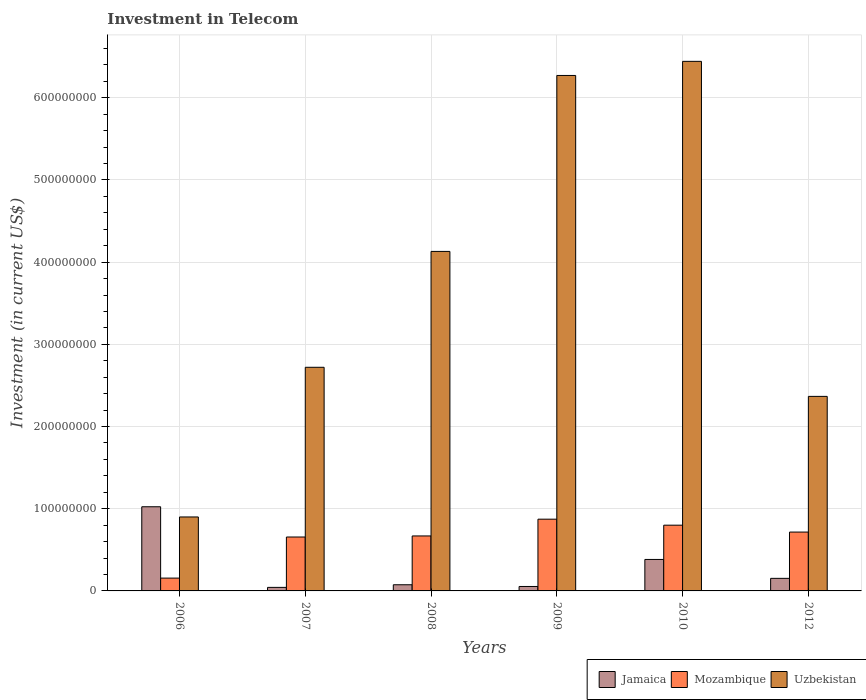How many groups of bars are there?
Your response must be concise. 6. Are the number of bars per tick equal to the number of legend labels?
Provide a short and direct response. Yes. Are the number of bars on each tick of the X-axis equal?
Make the answer very short. Yes. What is the label of the 1st group of bars from the left?
Offer a very short reply. 2006. What is the amount invested in telecom in Jamaica in 2006?
Your answer should be very brief. 1.02e+08. Across all years, what is the maximum amount invested in telecom in Uzbekistan?
Your answer should be compact. 6.44e+08. Across all years, what is the minimum amount invested in telecom in Uzbekistan?
Make the answer very short. 9.00e+07. What is the total amount invested in telecom in Uzbekistan in the graph?
Your answer should be compact. 2.28e+09. What is the difference between the amount invested in telecom in Mozambique in 2007 and that in 2008?
Provide a succinct answer. -1.30e+06. What is the difference between the amount invested in telecom in Jamaica in 2010 and the amount invested in telecom in Mozambique in 2006?
Offer a very short reply. 2.27e+07. What is the average amount invested in telecom in Mozambique per year?
Your answer should be compact. 6.45e+07. In the year 2009, what is the difference between the amount invested in telecom in Mozambique and amount invested in telecom in Jamaica?
Make the answer very short. 8.19e+07. What is the ratio of the amount invested in telecom in Mozambique in 2010 to that in 2012?
Your answer should be very brief. 1.12. Is the amount invested in telecom in Mozambique in 2008 less than that in 2012?
Keep it short and to the point. Yes. Is the difference between the amount invested in telecom in Mozambique in 2007 and 2012 greater than the difference between the amount invested in telecom in Jamaica in 2007 and 2012?
Your response must be concise. Yes. What is the difference between the highest and the second highest amount invested in telecom in Mozambique?
Give a very brief answer. 7.30e+06. What is the difference between the highest and the lowest amount invested in telecom in Uzbekistan?
Offer a terse response. 5.54e+08. Is the sum of the amount invested in telecom in Mozambique in 2008 and 2012 greater than the maximum amount invested in telecom in Jamaica across all years?
Provide a succinct answer. Yes. What does the 1st bar from the left in 2009 represents?
Your answer should be compact. Jamaica. What does the 3rd bar from the right in 2012 represents?
Your response must be concise. Jamaica. How many years are there in the graph?
Make the answer very short. 6. Are the values on the major ticks of Y-axis written in scientific E-notation?
Keep it short and to the point. No. How many legend labels are there?
Give a very brief answer. 3. What is the title of the graph?
Make the answer very short. Investment in Telecom. Does "Afghanistan" appear as one of the legend labels in the graph?
Ensure brevity in your answer.  No. What is the label or title of the X-axis?
Make the answer very short. Years. What is the label or title of the Y-axis?
Your answer should be very brief. Investment (in current US$). What is the Investment (in current US$) of Jamaica in 2006?
Offer a terse response. 1.02e+08. What is the Investment (in current US$) in Mozambique in 2006?
Provide a succinct answer. 1.56e+07. What is the Investment (in current US$) of Uzbekistan in 2006?
Your response must be concise. 9.00e+07. What is the Investment (in current US$) of Jamaica in 2007?
Keep it short and to the point. 4.30e+06. What is the Investment (in current US$) of Mozambique in 2007?
Your answer should be compact. 6.56e+07. What is the Investment (in current US$) of Uzbekistan in 2007?
Ensure brevity in your answer.  2.72e+08. What is the Investment (in current US$) of Jamaica in 2008?
Provide a short and direct response. 7.50e+06. What is the Investment (in current US$) of Mozambique in 2008?
Your answer should be compact. 6.69e+07. What is the Investment (in current US$) in Uzbekistan in 2008?
Offer a terse response. 4.13e+08. What is the Investment (in current US$) in Jamaica in 2009?
Your answer should be very brief. 5.40e+06. What is the Investment (in current US$) in Mozambique in 2009?
Your answer should be compact. 8.73e+07. What is the Investment (in current US$) in Uzbekistan in 2009?
Provide a succinct answer. 6.27e+08. What is the Investment (in current US$) in Jamaica in 2010?
Keep it short and to the point. 3.83e+07. What is the Investment (in current US$) of Mozambique in 2010?
Offer a very short reply. 8.00e+07. What is the Investment (in current US$) of Uzbekistan in 2010?
Keep it short and to the point. 6.44e+08. What is the Investment (in current US$) of Jamaica in 2012?
Offer a terse response. 1.53e+07. What is the Investment (in current US$) of Mozambique in 2012?
Keep it short and to the point. 7.16e+07. What is the Investment (in current US$) in Uzbekistan in 2012?
Provide a short and direct response. 2.37e+08. Across all years, what is the maximum Investment (in current US$) of Jamaica?
Provide a short and direct response. 1.02e+08. Across all years, what is the maximum Investment (in current US$) in Mozambique?
Give a very brief answer. 8.73e+07. Across all years, what is the maximum Investment (in current US$) of Uzbekistan?
Offer a very short reply. 6.44e+08. Across all years, what is the minimum Investment (in current US$) of Jamaica?
Make the answer very short. 4.30e+06. Across all years, what is the minimum Investment (in current US$) of Mozambique?
Make the answer very short. 1.56e+07. Across all years, what is the minimum Investment (in current US$) in Uzbekistan?
Make the answer very short. 9.00e+07. What is the total Investment (in current US$) in Jamaica in the graph?
Make the answer very short. 1.73e+08. What is the total Investment (in current US$) in Mozambique in the graph?
Make the answer very short. 3.87e+08. What is the total Investment (in current US$) of Uzbekistan in the graph?
Offer a terse response. 2.28e+09. What is the difference between the Investment (in current US$) in Jamaica in 2006 and that in 2007?
Provide a succinct answer. 9.81e+07. What is the difference between the Investment (in current US$) in Mozambique in 2006 and that in 2007?
Your response must be concise. -5.00e+07. What is the difference between the Investment (in current US$) of Uzbekistan in 2006 and that in 2007?
Your answer should be very brief. -1.82e+08. What is the difference between the Investment (in current US$) in Jamaica in 2006 and that in 2008?
Your answer should be compact. 9.49e+07. What is the difference between the Investment (in current US$) in Mozambique in 2006 and that in 2008?
Your response must be concise. -5.13e+07. What is the difference between the Investment (in current US$) in Uzbekistan in 2006 and that in 2008?
Your answer should be very brief. -3.23e+08. What is the difference between the Investment (in current US$) of Jamaica in 2006 and that in 2009?
Give a very brief answer. 9.70e+07. What is the difference between the Investment (in current US$) of Mozambique in 2006 and that in 2009?
Give a very brief answer. -7.17e+07. What is the difference between the Investment (in current US$) in Uzbekistan in 2006 and that in 2009?
Keep it short and to the point. -5.37e+08. What is the difference between the Investment (in current US$) of Jamaica in 2006 and that in 2010?
Offer a very short reply. 6.41e+07. What is the difference between the Investment (in current US$) of Mozambique in 2006 and that in 2010?
Offer a terse response. -6.44e+07. What is the difference between the Investment (in current US$) of Uzbekistan in 2006 and that in 2010?
Provide a short and direct response. -5.54e+08. What is the difference between the Investment (in current US$) in Jamaica in 2006 and that in 2012?
Your answer should be very brief. 8.71e+07. What is the difference between the Investment (in current US$) in Mozambique in 2006 and that in 2012?
Provide a short and direct response. -5.60e+07. What is the difference between the Investment (in current US$) of Uzbekistan in 2006 and that in 2012?
Offer a very short reply. -1.47e+08. What is the difference between the Investment (in current US$) of Jamaica in 2007 and that in 2008?
Ensure brevity in your answer.  -3.20e+06. What is the difference between the Investment (in current US$) in Mozambique in 2007 and that in 2008?
Provide a short and direct response. -1.30e+06. What is the difference between the Investment (in current US$) of Uzbekistan in 2007 and that in 2008?
Provide a succinct answer. -1.41e+08. What is the difference between the Investment (in current US$) of Jamaica in 2007 and that in 2009?
Ensure brevity in your answer.  -1.10e+06. What is the difference between the Investment (in current US$) in Mozambique in 2007 and that in 2009?
Ensure brevity in your answer.  -2.17e+07. What is the difference between the Investment (in current US$) of Uzbekistan in 2007 and that in 2009?
Provide a succinct answer. -3.55e+08. What is the difference between the Investment (in current US$) in Jamaica in 2007 and that in 2010?
Your answer should be compact. -3.40e+07. What is the difference between the Investment (in current US$) of Mozambique in 2007 and that in 2010?
Make the answer very short. -1.44e+07. What is the difference between the Investment (in current US$) of Uzbekistan in 2007 and that in 2010?
Your response must be concise. -3.72e+08. What is the difference between the Investment (in current US$) of Jamaica in 2007 and that in 2012?
Give a very brief answer. -1.10e+07. What is the difference between the Investment (in current US$) in Mozambique in 2007 and that in 2012?
Keep it short and to the point. -6.00e+06. What is the difference between the Investment (in current US$) of Uzbekistan in 2007 and that in 2012?
Provide a succinct answer. 3.54e+07. What is the difference between the Investment (in current US$) in Jamaica in 2008 and that in 2009?
Your answer should be very brief. 2.10e+06. What is the difference between the Investment (in current US$) of Mozambique in 2008 and that in 2009?
Provide a succinct answer. -2.04e+07. What is the difference between the Investment (in current US$) of Uzbekistan in 2008 and that in 2009?
Provide a short and direct response. -2.14e+08. What is the difference between the Investment (in current US$) in Jamaica in 2008 and that in 2010?
Your answer should be very brief. -3.08e+07. What is the difference between the Investment (in current US$) in Mozambique in 2008 and that in 2010?
Your answer should be compact. -1.31e+07. What is the difference between the Investment (in current US$) in Uzbekistan in 2008 and that in 2010?
Your response must be concise. -2.31e+08. What is the difference between the Investment (in current US$) in Jamaica in 2008 and that in 2012?
Offer a very short reply. -7.80e+06. What is the difference between the Investment (in current US$) of Mozambique in 2008 and that in 2012?
Offer a very short reply. -4.70e+06. What is the difference between the Investment (in current US$) in Uzbekistan in 2008 and that in 2012?
Offer a very short reply. 1.76e+08. What is the difference between the Investment (in current US$) in Jamaica in 2009 and that in 2010?
Offer a terse response. -3.29e+07. What is the difference between the Investment (in current US$) in Mozambique in 2009 and that in 2010?
Your answer should be compact. 7.30e+06. What is the difference between the Investment (in current US$) of Uzbekistan in 2009 and that in 2010?
Offer a very short reply. -1.72e+07. What is the difference between the Investment (in current US$) of Jamaica in 2009 and that in 2012?
Offer a terse response. -9.90e+06. What is the difference between the Investment (in current US$) of Mozambique in 2009 and that in 2012?
Provide a short and direct response. 1.57e+07. What is the difference between the Investment (in current US$) of Uzbekistan in 2009 and that in 2012?
Ensure brevity in your answer.  3.90e+08. What is the difference between the Investment (in current US$) of Jamaica in 2010 and that in 2012?
Offer a terse response. 2.30e+07. What is the difference between the Investment (in current US$) of Mozambique in 2010 and that in 2012?
Your response must be concise. 8.40e+06. What is the difference between the Investment (in current US$) in Uzbekistan in 2010 and that in 2012?
Give a very brief answer. 4.08e+08. What is the difference between the Investment (in current US$) of Jamaica in 2006 and the Investment (in current US$) of Mozambique in 2007?
Offer a terse response. 3.68e+07. What is the difference between the Investment (in current US$) of Jamaica in 2006 and the Investment (in current US$) of Uzbekistan in 2007?
Your answer should be very brief. -1.70e+08. What is the difference between the Investment (in current US$) of Mozambique in 2006 and the Investment (in current US$) of Uzbekistan in 2007?
Give a very brief answer. -2.56e+08. What is the difference between the Investment (in current US$) of Jamaica in 2006 and the Investment (in current US$) of Mozambique in 2008?
Keep it short and to the point. 3.55e+07. What is the difference between the Investment (in current US$) in Jamaica in 2006 and the Investment (in current US$) in Uzbekistan in 2008?
Offer a terse response. -3.11e+08. What is the difference between the Investment (in current US$) of Mozambique in 2006 and the Investment (in current US$) of Uzbekistan in 2008?
Your response must be concise. -3.98e+08. What is the difference between the Investment (in current US$) of Jamaica in 2006 and the Investment (in current US$) of Mozambique in 2009?
Your response must be concise. 1.51e+07. What is the difference between the Investment (in current US$) in Jamaica in 2006 and the Investment (in current US$) in Uzbekistan in 2009?
Offer a terse response. -5.25e+08. What is the difference between the Investment (in current US$) in Mozambique in 2006 and the Investment (in current US$) in Uzbekistan in 2009?
Your answer should be very brief. -6.12e+08. What is the difference between the Investment (in current US$) in Jamaica in 2006 and the Investment (in current US$) in Mozambique in 2010?
Make the answer very short. 2.24e+07. What is the difference between the Investment (in current US$) in Jamaica in 2006 and the Investment (in current US$) in Uzbekistan in 2010?
Keep it short and to the point. -5.42e+08. What is the difference between the Investment (in current US$) in Mozambique in 2006 and the Investment (in current US$) in Uzbekistan in 2010?
Your answer should be compact. -6.29e+08. What is the difference between the Investment (in current US$) of Jamaica in 2006 and the Investment (in current US$) of Mozambique in 2012?
Your response must be concise. 3.08e+07. What is the difference between the Investment (in current US$) in Jamaica in 2006 and the Investment (in current US$) in Uzbekistan in 2012?
Make the answer very short. -1.34e+08. What is the difference between the Investment (in current US$) of Mozambique in 2006 and the Investment (in current US$) of Uzbekistan in 2012?
Your response must be concise. -2.21e+08. What is the difference between the Investment (in current US$) of Jamaica in 2007 and the Investment (in current US$) of Mozambique in 2008?
Offer a very short reply. -6.26e+07. What is the difference between the Investment (in current US$) in Jamaica in 2007 and the Investment (in current US$) in Uzbekistan in 2008?
Ensure brevity in your answer.  -4.09e+08. What is the difference between the Investment (in current US$) of Mozambique in 2007 and the Investment (in current US$) of Uzbekistan in 2008?
Your response must be concise. -3.48e+08. What is the difference between the Investment (in current US$) of Jamaica in 2007 and the Investment (in current US$) of Mozambique in 2009?
Offer a terse response. -8.30e+07. What is the difference between the Investment (in current US$) in Jamaica in 2007 and the Investment (in current US$) in Uzbekistan in 2009?
Give a very brief answer. -6.23e+08. What is the difference between the Investment (in current US$) of Mozambique in 2007 and the Investment (in current US$) of Uzbekistan in 2009?
Offer a terse response. -5.62e+08. What is the difference between the Investment (in current US$) of Jamaica in 2007 and the Investment (in current US$) of Mozambique in 2010?
Keep it short and to the point. -7.57e+07. What is the difference between the Investment (in current US$) of Jamaica in 2007 and the Investment (in current US$) of Uzbekistan in 2010?
Provide a succinct answer. -6.40e+08. What is the difference between the Investment (in current US$) of Mozambique in 2007 and the Investment (in current US$) of Uzbekistan in 2010?
Offer a very short reply. -5.79e+08. What is the difference between the Investment (in current US$) of Jamaica in 2007 and the Investment (in current US$) of Mozambique in 2012?
Offer a terse response. -6.73e+07. What is the difference between the Investment (in current US$) in Jamaica in 2007 and the Investment (in current US$) in Uzbekistan in 2012?
Provide a succinct answer. -2.32e+08. What is the difference between the Investment (in current US$) of Mozambique in 2007 and the Investment (in current US$) of Uzbekistan in 2012?
Ensure brevity in your answer.  -1.71e+08. What is the difference between the Investment (in current US$) in Jamaica in 2008 and the Investment (in current US$) in Mozambique in 2009?
Keep it short and to the point. -7.98e+07. What is the difference between the Investment (in current US$) of Jamaica in 2008 and the Investment (in current US$) of Uzbekistan in 2009?
Keep it short and to the point. -6.20e+08. What is the difference between the Investment (in current US$) of Mozambique in 2008 and the Investment (in current US$) of Uzbekistan in 2009?
Offer a very short reply. -5.60e+08. What is the difference between the Investment (in current US$) in Jamaica in 2008 and the Investment (in current US$) in Mozambique in 2010?
Your answer should be very brief. -7.25e+07. What is the difference between the Investment (in current US$) in Jamaica in 2008 and the Investment (in current US$) in Uzbekistan in 2010?
Offer a terse response. -6.37e+08. What is the difference between the Investment (in current US$) in Mozambique in 2008 and the Investment (in current US$) in Uzbekistan in 2010?
Provide a short and direct response. -5.77e+08. What is the difference between the Investment (in current US$) in Jamaica in 2008 and the Investment (in current US$) in Mozambique in 2012?
Your answer should be very brief. -6.41e+07. What is the difference between the Investment (in current US$) in Jamaica in 2008 and the Investment (in current US$) in Uzbekistan in 2012?
Your response must be concise. -2.29e+08. What is the difference between the Investment (in current US$) in Mozambique in 2008 and the Investment (in current US$) in Uzbekistan in 2012?
Provide a short and direct response. -1.70e+08. What is the difference between the Investment (in current US$) in Jamaica in 2009 and the Investment (in current US$) in Mozambique in 2010?
Give a very brief answer. -7.46e+07. What is the difference between the Investment (in current US$) in Jamaica in 2009 and the Investment (in current US$) in Uzbekistan in 2010?
Offer a terse response. -6.39e+08. What is the difference between the Investment (in current US$) of Mozambique in 2009 and the Investment (in current US$) of Uzbekistan in 2010?
Offer a very short reply. -5.57e+08. What is the difference between the Investment (in current US$) in Jamaica in 2009 and the Investment (in current US$) in Mozambique in 2012?
Keep it short and to the point. -6.62e+07. What is the difference between the Investment (in current US$) of Jamaica in 2009 and the Investment (in current US$) of Uzbekistan in 2012?
Provide a succinct answer. -2.31e+08. What is the difference between the Investment (in current US$) of Mozambique in 2009 and the Investment (in current US$) of Uzbekistan in 2012?
Offer a very short reply. -1.49e+08. What is the difference between the Investment (in current US$) of Jamaica in 2010 and the Investment (in current US$) of Mozambique in 2012?
Provide a succinct answer. -3.33e+07. What is the difference between the Investment (in current US$) of Jamaica in 2010 and the Investment (in current US$) of Uzbekistan in 2012?
Provide a succinct answer. -1.98e+08. What is the difference between the Investment (in current US$) of Mozambique in 2010 and the Investment (in current US$) of Uzbekistan in 2012?
Give a very brief answer. -1.57e+08. What is the average Investment (in current US$) of Jamaica per year?
Your answer should be very brief. 2.89e+07. What is the average Investment (in current US$) in Mozambique per year?
Provide a succinct answer. 6.45e+07. What is the average Investment (in current US$) in Uzbekistan per year?
Make the answer very short. 3.81e+08. In the year 2006, what is the difference between the Investment (in current US$) of Jamaica and Investment (in current US$) of Mozambique?
Your answer should be very brief. 8.68e+07. In the year 2006, what is the difference between the Investment (in current US$) of Jamaica and Investment (in current US$) of Uzbekistan?
Ensure brevity in your answer.  1.24e+07. In the year 2006, what is the difference between the Investment (in current US$) in Mozambique and Investment (in current US$) in Uzbekistan?
Your answer should be very brief. -7.44e+07. In the year 2007, what is the difference between the Investment (in current US$) of Jamaica and Investment (in current US$) of Mozambique?
Offer a very short reply. -6.13e+07. In the year 2007, what is the difference between the Investment (in current US$) in Jamaica and Investment (in current US$) in Uzbekistan?
Your answer should be compact. -2.68e+08. In the year 2007, what is the difference between the Investment (in current US$) of Mozambique and Investment (in current US$) of Uzbekistan?
Give a very brief answer. -2.06e+08. In the year 2008, what is the difference between the Investment (in current US$) of Jamaica and Investment (in current US$) of Mozambique?
Give a very brief answer. -5.94e+07. In the year 2008, what is the difference between the Investment (in current US$) of Jamaica and Investment (in current US$) of Uzbekistan?
Provide a succinct answer. -4.06e+08. In the year 2008, what is the difference between the Investment (in current US$) of Mozambique and Investment (in current US$) of Uzbekistan?
Make the answer very short. -3.46e+08. In the year 2009, what is the difference between the Investment (in current US$) of Jamaica and Investment (in current US$) of Mozambique?
Provide a short and direct response. -8.19e+07. In the year 2009, what is the difference between the Investment (in current US$) of Jamaica and Investment (in current US$) of Uzbekistan?
Your answer should be very brief. -6.22e+08. In the year 2009, what is the difference between the Investment (in current US$) in Mozambique and Investment (in current US$) in Uzbekistan?
Make the answer very short. -5.40e+08. In the year 2010, what is the difference between the Investment (in current US$) in Jamaica and Investment (in current US$) in Mozambique?
Provide a succinct answer. -4.17e+07. In the year 2010, what is the difference between the Investment (in current US$) of Jamaica and Investment (in current US$) of Uzbekistan?
Your response must be concise. -6.06e+08. In the year 2010, what is the difference between the Investment (in current US$) in Mozambique and Investment (in current US$) in Uzbekistan?
Ensure brevity in your answer.  -5.64e+08. In the year 2012, what is the difference between the Investment (in current US$) in Jamaica and Investment (in current US$) in Mozambique?
Your answer should be very brief. -5.63e+07. In the year 2012, what is the difference between the Investment (in current US$) of Jamaica and Investment (in current US$) of Uzbekistan?
Offer a very short reply. -2.21e+08. In the year 2012, what is the difference between the Investment (in current US$) in Mozambique and Investment (in current US$) in Uzbekistan?
Ensure brevity in your answer.  -1.65e+08. What is the ratio of the Investment (in current US$) in Jamaica in 2006 to that in 2007?
Make the answer very short. 23.81. What is the ratio of the Investment (in current US$) of Mozambique in 2006 to that in 2007?
Your response must be concise. 0.24. What is the ratio of the Investment (in current US$) of Uzbekistan in 2006 to that in 2007?
Provide a succinct answer. 0.33. What is the ratio of the Investment (in current US$) in Jamaica in 2006 to that in 2008?
Your answer should be very brief. 13.65. What is the ratio of the Investment (in current US$) of Mozambique in 2006 to that in 2008?
Your answer should be very brief. 0.23. What is the ratio of the Investment (in current US$) of Uzbekistan in 2006 to that in 2008?
Your answer should be compact. 0.22. What is the ratio of the Investment (in current US$) in Jamaica in 2006 to that in 2009?
Ensure brevity in your answer.  18.96. What is the ratio of the Investment (in current US$) of Mozambique in 2006 to that in 2009?
Ensure brevity in your answer.  0.18. What is the ratio of the Investment (in current US$) in Uzbekistan in 2006 to that in 2009?
Provide a short and direct response. 0.14. What is the ratio of the Investment (in current US$) in Jamaica in 2006 to that in 2010?
Your answer should be compact. 2.67. What is the ratio of the Investment (in current US$) in Mozambique in 2006 to that in 2010?
Ensure brevity in your answer.  0.2. What is the ratio of the Investment (in current US$) in Uzbekistan in 2006 to that in 2010?
Ensure brevity in your answer.  0.14. What is the ratio of the Investment (in current US$) of Jamaica in 2006 to that in 2012?
Your answer should be compact. 6.69. What is the ratio of the Investment (in current US$) of Mozambique in 2006 to that in 2012?
Ensure brevity in your answer.  0.22. What is the ratio of the Investment (in current US$) of Uzbekistan in 2006 to that in 2012?
Give a very brief answer. 0.38. What is the ratio of the Investment (in current US$) of Jamaica in 2007 to that in 2008?
Your response must be concise. 0.57. What is the ratio of the Investment (in current US$) in Mozambique in 2007 to that in 2008?
Give a very brief answer. 0.98. What is the ratio of the Investment (in current US$) of Uzbekistan in 2007 to that in 2008?
Provide a short and direct response. 0.66. What is the ratio of the Investment (in current US$) in Jamaica in 2007 to that in 2009?
Offer a very short reply. 0.8. What is the ratio of the Investment (in current US$) in Mozambique in 2007 to that in 2009?
Provide a succinct answer. 0.75. What is the ratio of the Investment (in current US$) in Uzbekistan in 2007 to that in 2009?
Your answer should be compact. 0.43. What is the ratio of the Investment (in current US$) in Jamaica in 2007 to that in 2010?
Offer a terse response. 0.11. What is the ratio of the Investment (in current US$) in Mozambique in 2007 to that in 2010?
Your answer should be very brief. 0.82. What is the ratio of the Investment (in current US$) of Uzbekistan in 2007 to that in 2010?
Ensure brevity in your answer.  0.42. What is the ratio of the Investment (in current US$) of Jamaica in 2007 to that in 2012?
Your answer should be compact. 0.28. What is the ratio of the Investment (in current US$) in Mozambique in 2007 to that in 2012?
Give a very brief answer. 0.92. What is the ratio of the Investment (in current US$) in Uzbekistan in 2007 to that in 2012?
Keep it short and to the point. 1.15. What is the ratio of the Investment (in current US$) of Jamaica in 2008 to that in 2009?
Provide a short and direct response. 1.39. What is the ratio of the Investment (in current US$) of Mozambique in 2008 to that in 2009?
Offer a terse response. 0.77. What is the ratio of the Investment (in current US$) in Uzbekistan in 2008 to that in 2009?
Provide a short and direct response. 0.66. What is the ratio of the Investment (in current US$) of Jamaica in 2008 to that in 2010?
Offer a very short reply. 0.2. What is the ratio of the Investment (in current US$) in Mozambique in 2008 to that in 2010?
Offer a terse response. 0.84. What is the ratio of the Investment (in current US$) in Uzbekistan in 2008 to that in 2010?
Your response must be concise. 0.64. What is the ratio of the Investment (in current US$) in Jamaica in 2008 to that in 2012?
Your answer should be very brief. 0.49. What is the ratio of the Investment (in current US$) in Mozambique in 2008 to that in 2012?
Your response must be concise. 0.93. What is the ratio of the Investment (in current US$) of Uzbekistan in 2008 to that in 2012?
Your answer should be compact. 1.75. What is the ratio of the Investment (in current US$) of Jamaica in 2009 to that in 2010?
Ensure brevity in your answer.  0.14. What is the ratio of the Investment (in current US$) in Mozambique in 2009 to that in 2010?
Give a very brief answer. 1.09. What is the ratio of the Investment (in current US$) of Uzbekistan in 2009 to that in 2010?
Give a very brief answer. 0.97. What is the ratio of the Investment (in current US$) in Jamaica in 2009 to that in 2012?
Give a very brief answer. 0.35. What is the ratio of the Investment (in current US$) of Mozambique in 2009 to that in 2012?
Offer a terse response. 1.22. What is the ratio of the Investment (in current US$) in Uzbekistan in 2009 to that in 2012?
Provide a succinct answer. 2.65. What is the ratio of the Investment (in current US$) of Jamaica in 2010 to that in 2012?
Give a very brief answer. 2.5. What is the ratio of the Investment (in current US$) in Mozambique in 2010 to that in 2012?
Your response must be concise. 1.12. What is the ratio of the Investment (in current US$) in Uzbekistan in 2010 to that in 2012?
Provide a short and direct response. 2.72. What is the difference between the highest and the second highest Investment (in current US$) of Jamaica?
Ensure brevity in your answer.  6.41e+07. What is the difference between the highest and the second highest Investment (in current US$) of Mozambique?
Ensure brevity in your answer.  7.30e+06. What is the difference between the highest and the second highest Investment (in current US$) of Uzbekistan?
Ensure brevity in your answer.  1.72e+07. What is the difference between the highest and the lowest Investment (in current US$) of Jamaica?
Your response must be concise. 9.81e+07. What is the difference between the highest and the lowest Investment (in current US$) of Mozambique?
Make the answer very short. 7.17e+07. What is the difference between the highest and the lowest Investment (in current US$) in Uzbekistan?
Your answer should be very brief. 5.54e+08. 